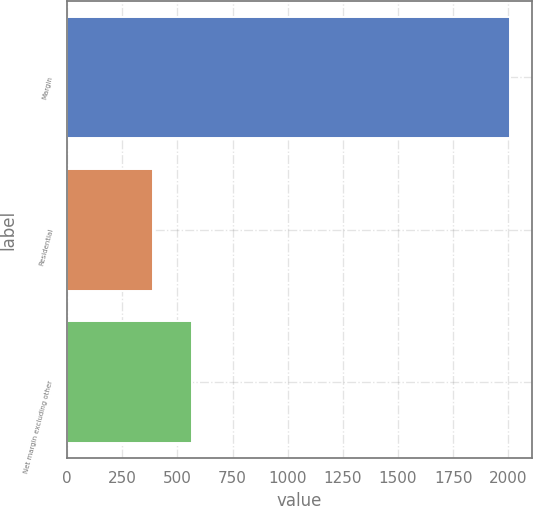Convert chart to OTSL. <chart><loc_0><loc_0><loc_500><loc_500><bar_chart><fcel>Margin<fcel>Residential<fcel>Net margin excluding other<nl><fcel>2006<fcel>390.2<fcel>566.8<nl></chart> 